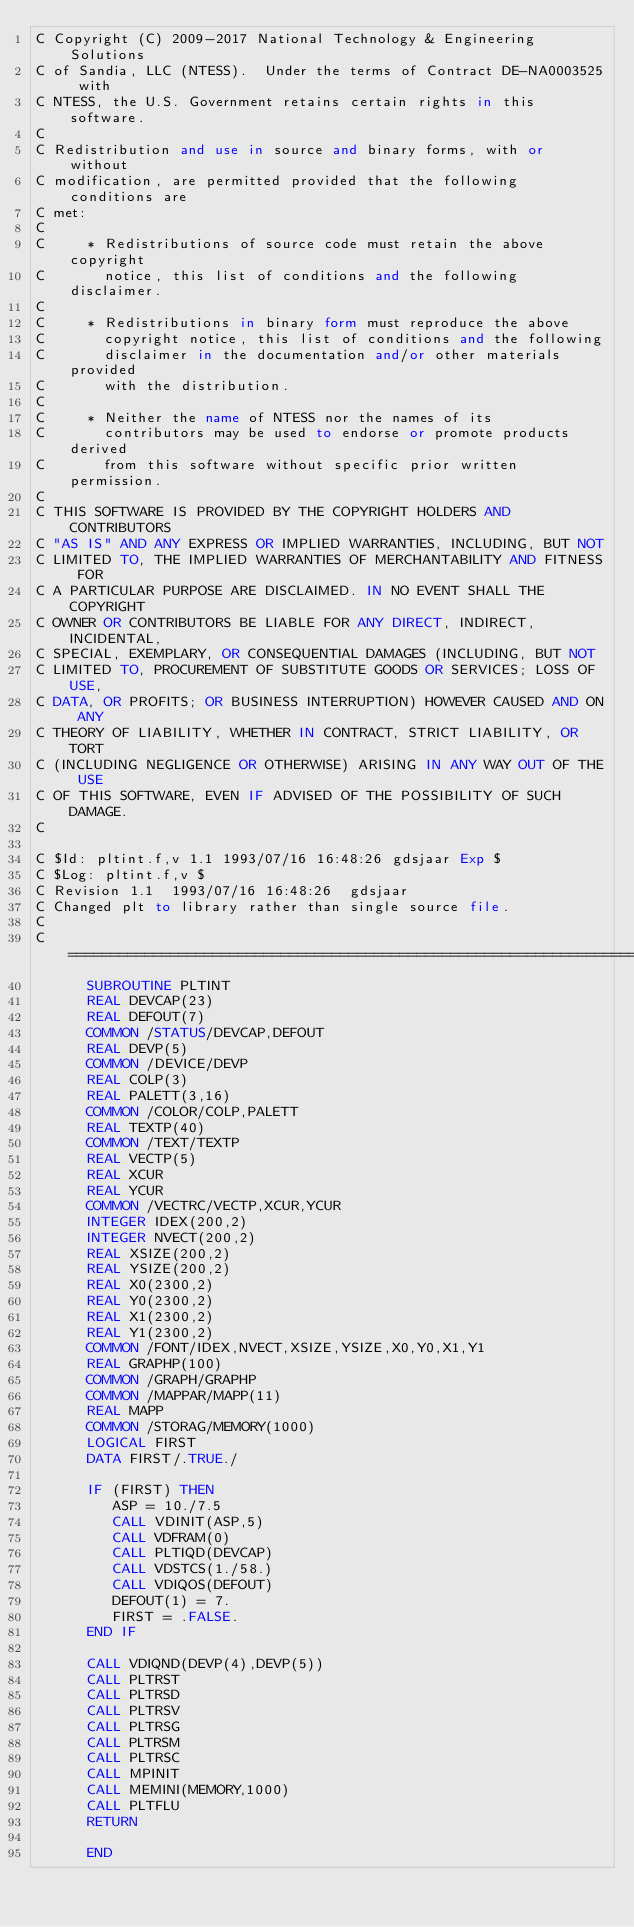Convert code to text. <code><loc_0><loc_0><loc_500><loc_500><_FORTRAN_>C Copyright (C) 2009-2017 National Technology & Engineering Solutions
C of Sandia, LLC (NTESS).  Under the terms of Contract DE-NA0003525 with
C NTESS, the U.S. Government retains certain rights in this software.
C 
C Redistribution and use in source and binary forms, with or without
C modification, are permitted provided that the following conditions are
C met:
C 
C     * Redistributions of source code must retain the above copyright
C       notice, this list of conditions and the following disclaimer.
C 
C     * Redistributions in binary form must reproduce the above
C       copyright notice, this list of conditions and the following
C       disclaimer in the documentation and/or other materials provided
C       with the distribution.
C 
C     * Neither the name of NTESS nor the names of its
C       contributors may be used to endorse or promote products derived
C       from this software without specific prior written permission.
C 
C THIS SOFTWARE IS PROVIDED BY THE COPYRIGHT HOLDERS AND CONTRIBUTORS
C "AS IS" AND ANY EXPRESS OR IMPLIED WARRANTIES, INCLUDING, BUT NOT
C LIMITED TO, THE IMPLIED WARRANTIES OF MERCHANTABILITY AND FITNESS FOR
C A PARTICULAR PURPOSE ARE DISCLAIMED. IN NO EVENT SHALL THE COPYRIGHT
C OWNER OR CONTRIBUTORS BE LIABLE FOR ANY DIRECT, INDIRECT, INCIDENTAL,
C SPECIAL, EXEMPLARY, OR CONSEQUENTIAL DAMAGES (INCLUDING, BUT NOT
C LIMITED TO, PROCUREMENT OF SUBSTITUTE GOODS OR SERVICES; LOSS OF USE,
C DATA, OR PROFITS; OR BUSINESS INTERRUPTION) HOWEVER CAUSED AND ON ANY
C THEORY OF LIABILITY, WHETHER IN CONTRACT, STRICT LIABILITY, OR TORT
C (INCLUDING NEGLIGENCE OR OTHERWISE) ARISING IN ANY WAY OUT OF THE USE
C OF THIS SOFTWARE, EVEN IF ADVISED OF THE POSSIBILITY OF SUCH DAMAGE.
C 

C $Id: pltint.f,v 1.1 1993/07/16 16:48:26 gdsjaar Exp $ 
C $Log: pltint.f,v $
C Revision 1.1  1993/07/16 16:48:26  gdsjaar
C Changed plt to library rather than single source file.
C 
C=======================================================================
      SUBROUTINE PLTINT
      REAL DEVCAP(23)
      REAL DEFOUT(7)
      COMMON /STATUS/DEVCAP,DEFOUT
      REAL DEVP(5)
      COMMON /DEVICE/DEVP
      REAL COLP(3)
      REAL PALETT(3,16)
      COMMON /COLOR/COLP,PALETT
      REAL TEXTP(40)
      COMMON /TEXT/TEXTP
      REAL VECTP(5)
      REAL XCUR
      REAL YCUR
      COMMON /VECTRC/VECTP,XCUR,YCUR
      INTEGER IDEX(200,2)
      INTEGER NVECT(200,2)
      REAL XSIZE(200,2)
      REAL YSIZE(200,2)
      REAL X0(2300,2)
      REAL Y0(2300,2)
      REAL X1(2300,2)
      REAL Y1(2300,2)
      COMMON /FONT/IDEX,NVECT,XSIZE,YSIZE,X0,Y0,X1,Y1
      REAL GRAPHP(100)
      COMMON /GRAPH/GRAPHP
      COMMON /MAPPAR/MAPP(11)
      REAL MAPP
      COMMON /STORAG/MEMORY(1000)
      LOGICAL FIRST
      DATA FIRST/.TRUE./

      IF (FIRST) THEN
         ASP = 10./7.5
         CALL VDINIT(ASP,5)
         CALL VDFRAM(0)
         CALL PLTIQD(DEVCAP)
         CALL VDSTCS(1./58.)
         CALL VDIQOS(DEFOUT)
         DEFOUT(1) = 7.
         FIRST = .FALSE.
      END IF

      CALL VDIQND(DEVP(4),DEVP(5))
      CALL PLTRST
      CALL PLTRSD
      CALL PLTRSV
      CALL PLTRSG
      CALL PLTRSM
      CALL PLTRSC
      CALL MPINIT
      CALL MEMINI(MEMORY,1000)
      CALL PLTFLU
      RETURN

      END
</code> 